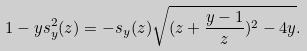<formula> <loc_0><loc_0><loc_500><loc_500>1 - y s _ { y } ^ { 2 } ( z ) = - s _ { y } ( z ) \sqrt { ( z + \frac { y - 1 } z ) ^ { 2 } - 4 y } .</formula> 